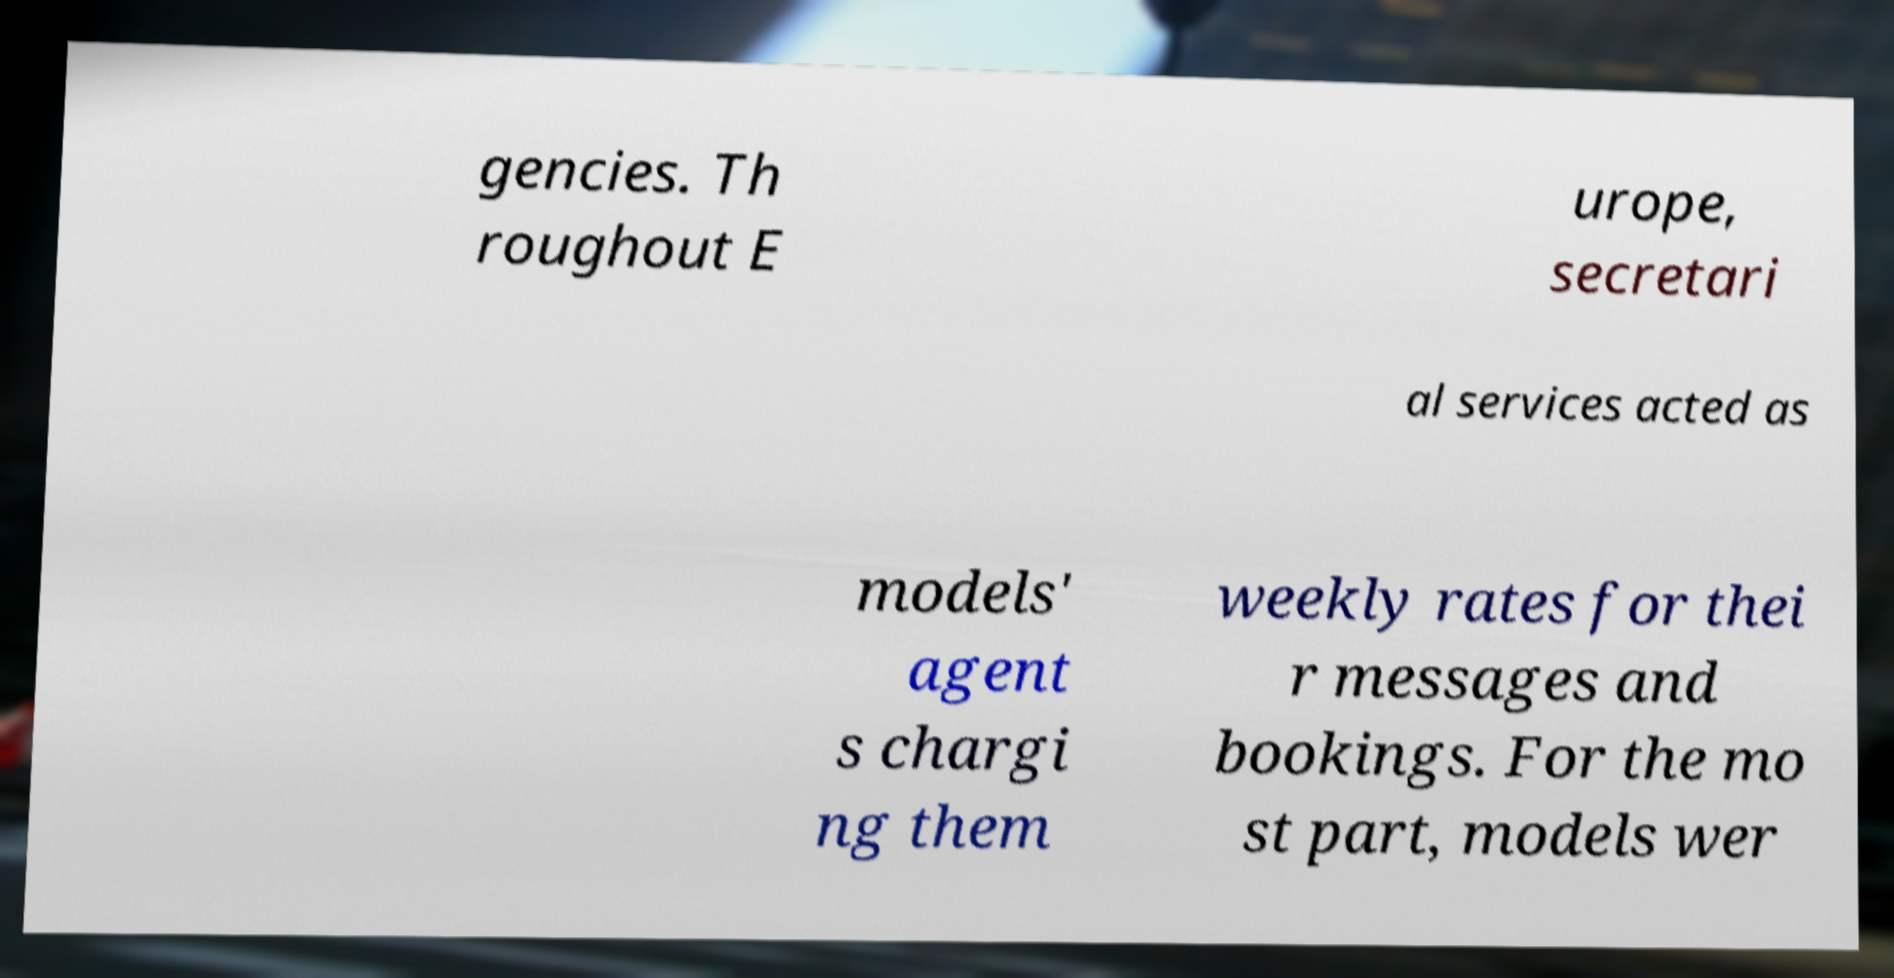For documentation purposes, I need the text within this image transcribed. Could you provide that? gencies. Th roughout E urope, secretari al services acted as models' agent s chargi ng them weekly rates for thei r messages and bookings. For the mo st part, models wer 